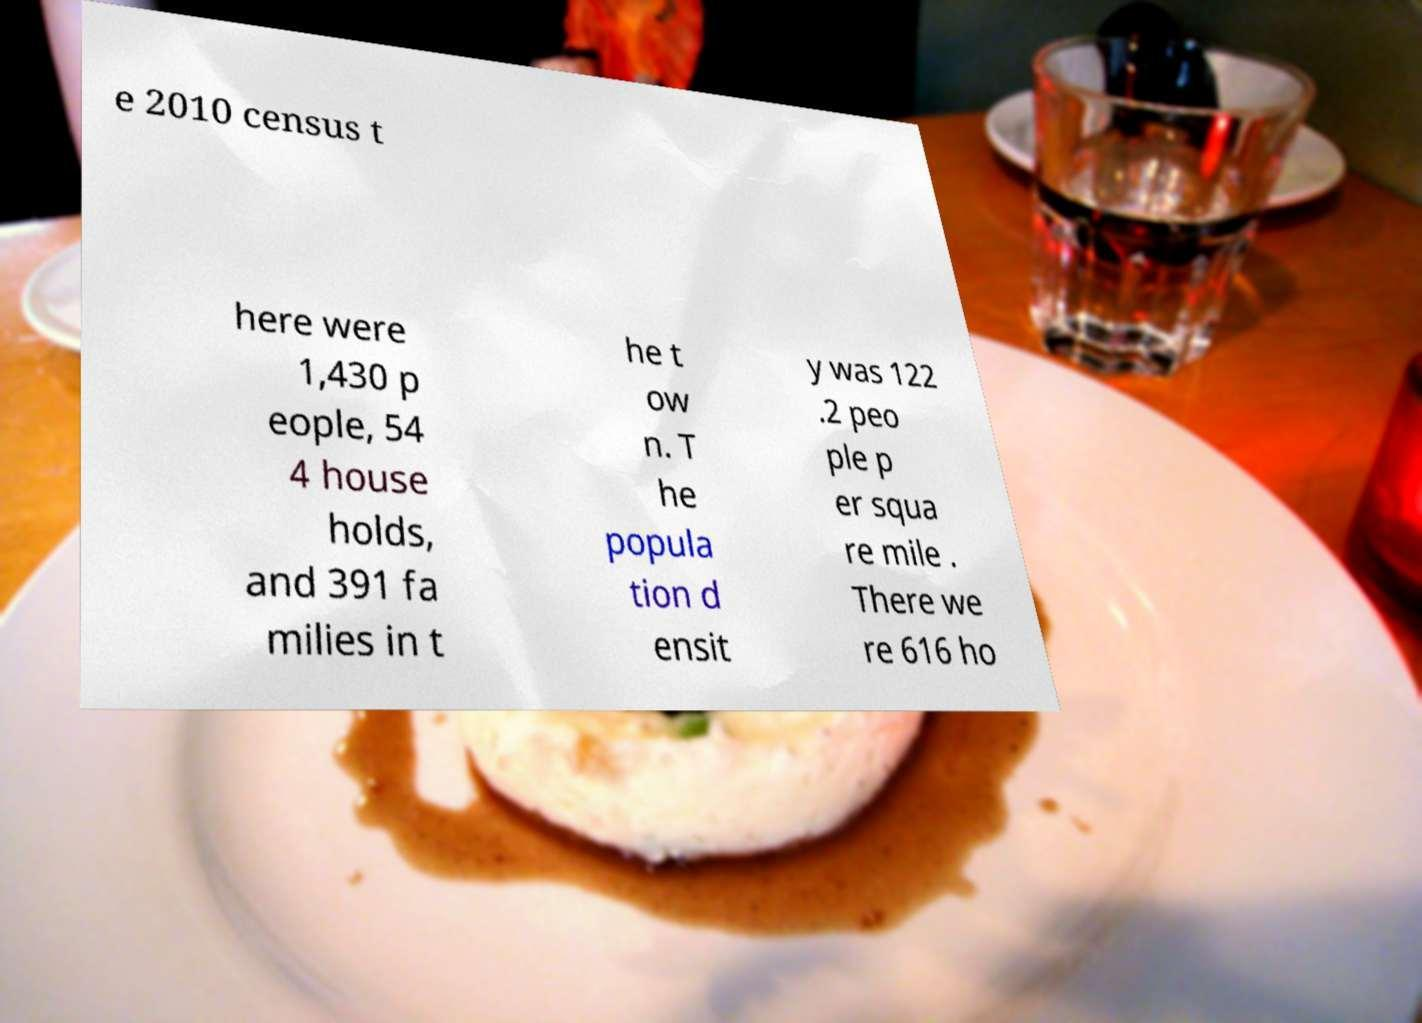Can you accurately transcribe the text from the provided image for me? e 2010 census t here were 1,430 p eople, 54 4 house holds, and 391 fa milies in t he t ow n. T he popula tion d ensit y was 122 .2 peo ple p er squa re mile . There we re 616 ho 